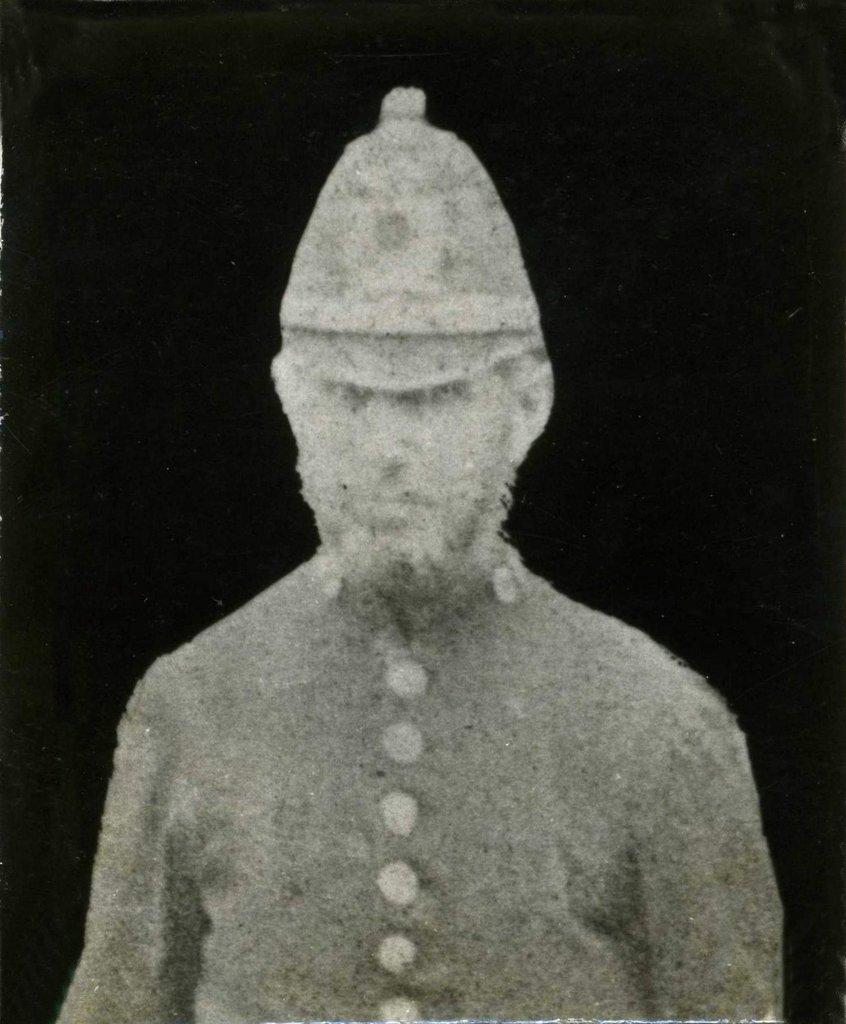Who or what is the main subject of the image? There is a person in the center of the image. What is the person wearing on their head? The person is wearing a hat. How would you describe the overall lighting or color of the image? The background of the image is dark. Can you tell if any post-processing or editing has been done to the image? Yes, the image has been edited. What type of square object can be seen in the person's hand in the image? There is no square object visible in the person's hand in the image. What language is the person speaking in the image? The image is a still photograph and does not capture any spoken language. 